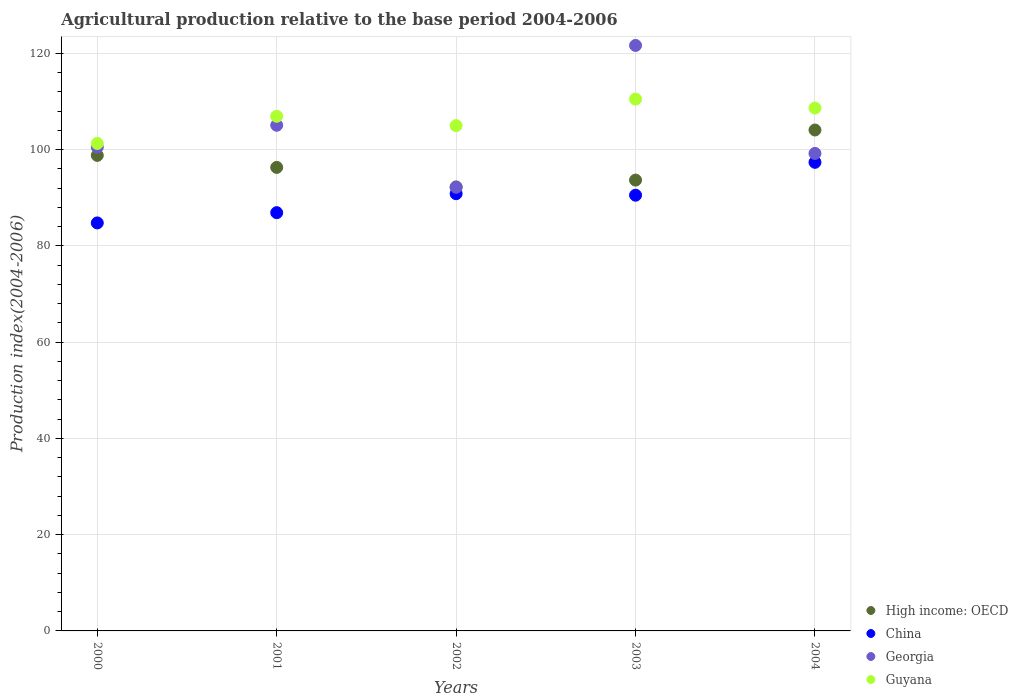Is the number of dotlines equal to the number of legend labels?
Offer a very short reply. Yes. What is the agricultural production index in Guyana in 2003?
Make the answer very short. 110.49. Across all years, what is the maximum agricultural production index in High income: OECD?
Ensure brevity in your answer.  104.06. Across all years, what is the minimum agricultural production index in Guyana?
Ensure brevity in your answer.  101.27. In which year was the agricultural production index in Georgia minimum?
Offer a very short reply. 2002. What is the total agricultural production index in Guyana in the graph?
Ensure brevity in your answer.  532.26. What is the difference between the agricultural production index in High income: OECD in 2000 and that in 2001?
Provide a succinct answer. 2.49. What is the difference between the agricultural production index in Guyana in 2003 and the agricultural production index in Georgia in 2000?
Offer a terse response. 9.99. What is the average agricultural production index in China per year?
Your response must be concise. 90.07. In the year 2003, what is the difference between the agricultural production index in Georgia and agricultural production index in China?
Make the answer very short. 31.11. What is the ratio of the agricultural production index in Georgia in 2000 to that in 2002?
Your answer should be compact. 1.09. Is the agricultural production index in Guyana in 2002 less than that in 2004?
Keep it short and to the point. Yes. Is the difference between the agricultural production index in Georgia in 2002 and 2004 greater than the difference between the agricultural production index in China in 2002 and 2004?
Provide a short and direct response. No. What is the difference between the highest and the second highest agricultural production index in China?
Your answer should be very brief. 6.52. What is the difference between the highest and the lowest agricultural production index in High income: OECD?
Provide a succinct answer. 11.82. Is it the case that in every year, the sum of the agricultural production index in High income: OECD and agricultural production index in China  is greater than the sum of agricultural production index in Georgia and agricultural production index in Guyana?
Ensure brevity in your answer.  No. Does the agricultural production index in Guyana monotonically increase over the years?
Provide a short and direct response. No. What is the difference between two consecutive major ticks on the Y-axis?
Offer a terse response. 20. Does the graph contain grids?
Offer a very short reply. Yes. How many legend labels are there?
Your answer should be very brief. 4. What is the title of the graph?
Your answer should be compact. Agricultural production relative to the base period 2004-2006. What is the label or title of the Y-axis?
Provide a short and direct response. Production index(2004-2006). What is the Production index(2004-2006) in High income: OECD in 2000?
Provide a succinct answer. 98.79. What is the Production index(2004-2006) in China in 2000?
Your answer should be very brief. 84.76. What is the Production index(2004-2006) of Georgia in 2000?
Your response must be concise. 100.5. What is the Production index(2004-2006) in Guyana in 2000?
Provide a succinct answer. 101.27. What is the Production index(2004-2006) of High income: OECD in 2001?
Keep it short and to the point. 96.3. What is the Production index(2004-2006) in China in 2001?
Your response must be concise. 86.89. What is the Production index(2004-2006) of Georgia in 2001?
Make the answer very short. 105.05. What is the Production index(2004-2006) of Guyana in 2001?
Your answer should be very brief. 106.91. What is the Production index(2004-2006) in High income: OECD in 2002?
Your answer should be compact. 92.24. What is the Production index(2004-2006) of China in 2002?
Your response must be concise. 90.83. What is the Production index(2004-2006) of Georgia in 2002?
Your answer should be compact. 92.16. What is the Production index(2004-2006) of Guyana in 2002?
Offer a terse response. 104.97. What is the Production index(2004-2006) of High income: OECD in 2003?
Make the answer very short. 93.66. What is the Production index(2004-2006) of China in 2003?
Your answer should be very brief. 90.52. What is the Production index(2004-2006) in Georgia in 2003?
Your answer should be very brief. 121.63. What is the Production index(2004-2006) in Guyana in 2003?
Keep it short and to the point. 110.49. What is the Production index(2004-2006) of High income: OECD in 2004?
Your answer should be very brief. 104.06. What is the Production index(2004-2006) in China in 2004?
Offer a very short reply. 97.35. What is the Production index(2004-2006) in Georgia in 2004?
Offer a terse response. 99.2. What is the Production index(2004-2006) of Guyana in 2004?
Give a very brief answer. 108.62. Across all years, what is the maximum Production index(2004-2006) in High income: OECD?
Ensure brevity in your answer.  104.06. Across all years, what is the maximum Production index(2004-2006) of China?
Keep it short and to the point. 97.35. Across all years, what is the maximum Production index(2004-2006) of Georgia?
Make the answer very short. 121.63. Across all years, what is the maximum Production index(2004-2006) in Guyana?
Your answer should be very brief. 110.49. Across all years, what is the minimum Production index(2004-2006) of High income: OECD?
Your response must be concise. 92.24. Across all years, what is the minimum Production index(2004-2006) of China?
Offer a terse response. 84.76. Across all years, what is the minimum Production index(2004-2006) of Georgia?
Offer a very short reply. 92.16. Across all years, what is the minimum Production index(2004-2006) of Guyana?
Your answer should be very brief. 101.27. What is the total Production index(2004-2006) in High income: OECD in the graph?
Offer a terse response. 485.04. What is the total Production index(2004-2006) in China in the graph?
Offer a terse response. 450.35. What is the total Production index(2004-2006) in Georgia in the graph?
Keep it short and to the point. 518.54. What is the total Production index(2004-2006) in Guyana in the graph?
Provide a succinct answer. 532.26. What is the difference between the Production index(2004-2006) of High income: OECD in 2000 and that in 2001?
Your answer should be very brief. 2.49. What is the difference between the Production index(2004-2006) of China in 2000 and that in 2001?
Provide a short and direct response. -2.13. What is the difference between the Production index(2004-2006) in Georgia in 2000 and that in 2001?
Your answer should be compact. -4.55. What is the difference between the Production index(2004-2006) of Guyana in 2000 and that in 2001?
Provide a succinct answer. -5.64. What is the difference between the Production index(2004-2006) of High income: OECD in 2000 and that in 2002?
Your response must be concise. 6.55. What is the difference between the Production index(2004-2006) of China in 2000 and that in 2002?
Your answer should be very brief. -6.07. What is the difference between the Production index(2004-2006) of Georgia in 2000 and that in 2002?
Your answer should be compact. 8.34. What is the difference between the Production index(2004-2006) in High income: OECD in 2000 and that in 2003?
Ensure brevity in your answer.  5.13. What is the difference between the Production index(2004-2006) in China in 2000 and that in 2003?
Your answer should be compact. -5.76. What is the difference between the Production index(2004-2006) in Georgia in 2000 and that in 2003?
Your response must be concise. -21.13. What is the difference between the Production index(2004-2006) of Guyana in 2000 and that in 2003?
Keep it short and to the point. -9.22. What is the difference between the Production index(2004-2006) of High income: OECD in 2000 and that in 2004?
Provide a succinct answer. -5.27. What is the difference between the Production index(2004-2006) of China in 2000 and that in 2004?
Ensure brevity in your answer.  -12.59. What is the difference between the Production index(2004-2006) in Guyana in 2000 and that in 2004?
Provide a succinct answer. -7.35. What is the difference between the Production index(2004-2006) of High income: OECD in 2001 and that in 2002?
Your answer should be very brief. 4.06. What is the difference between the Production index(2004-2006) of China in 2001 and that in 2002?
Offer a terse response. -3.94. What is the difference between the Production index(2004-2006) of Georgia in 2001 and that in 2002?
Give a very brief answer. 12.89. What is the difference between the Production index(2004-2006) of Guyana in 2001 and that in 2002?
Offer a terse response. 1.94. What is the difference between the Production index(2004-2006) in High income: OECD in 2001 and that in 2003?
Provide a succinct answer. 2.64. What is the difference between the Production index(2004-2006) of China in 2001 and that in 2003?
Ensure brevity in your answer.  -3.63. What is the difference between the Production index(2004-2006) of Georgia in 2001 and that in 2003?
Keep it short and to the point. -16.58. What is the difference between the Production index(2004-2006) in Guyana in 2001 and that in 2003?
Provide a succinct answer. -3.58. What is the difference between the Production index(2004-2006) in High income: OECD in 2001 and that in 2004?
Your response must be concise. -7.77. What is the difference between the Production index(2004-2006) in China in 2001 and that in 2004?
Make the answer very short. -10.46. What is the difference between the Production index(2004-2006) of Georgia in 2001 and that in 2004?
Keep it short and to the point. 5.85. What is the difference between the Production index(2004-2006) of Guyana in 2001 and that in 2004?
Provide a succinct answer. -1.71. What is the difference between the Production index(2004-2006) of High income: OECD in 2002 and that in 2003?
Make the answer very short. -1.42. What is the difference between the Production index(2004-2006) of China in 2002 and that in 2003?
Ensure brevity in your answer.  0.31. What is the difference between the Production index(2004-2006) of Georgia in 2002 and that in 2003?
Offer a very short reply. -29.47. What is the difference between the Production index(2004-2006) of Guyana in 2002 and that in 2003?
Offer a terse response. -5.52. What is the difference between the Production index(2004-2006) in High income: OECD in 2002 and that in 2004?
Provide a short and direct response. -11.82. What is the difference between the Production index(2004-2006) in China in 2002 and that in 2004?
Make the answer very short. -6.52. What is the difference between the Production index(2004-2006) in Georgia in 2002 and that in 2004?
Give a very brief answer. -7.04. What is the difference between the Production index(2004-2006) of Guyana in 2002 and that in 2004?
Provide a short and direct response. -3.65. What is the difference between the Production index(2004-2006) in High income: OECD in 2003 and that in 2004?
Provide a short and direct response. -10.41. What is the difference between the Production index(2004-2006) of China in 2003 and that in 2004?
Offer a terse response. -6.83. What is the difference between the Production index(2004-2006) of Georgia in 2003 and that in 2004?
Ensure brevity in your answer.  22.43. What is the difference between the Production index(2004-2006) in Guyana in 2003 and that in 2004?
Give a very brief answer. 1.87. What is the difference between the Production index(2004-2006) of High income: OECD in 2000 and the Production index(2004-2006) of China in 2001?
Give a very brief answer. 11.9. What is the difference between the Production index(2004-2006) of High income: OECD in 2000 and the Production index(2004-2006) of Georgia in 2001?
Your answer should be compact. -6.26. What is the difference between the Production index(2004-2006) in High income: OECD in 2000 and the Production index(2004-2006) in Guyana in 2001?
Make the answer very short. -8.12. What is the difference between the Production index(2004-2006) in China in 2000 and the Production index(2004-2006) in Georgia in 2001?
Your response must be concise. -20.29. What is the difference between the Production index(2004-2006) of China in 2000 and the Production index(2004-2006) of Guyana in 2001?
Offer a terse response. -22.15. What is the difference between the Production index(2004-2006) of Georgia in 2000 and the Production index(2004-2006) of Guyana in 2001?
Provide a succinct answer. -6.41. What is the difference between the Production index(2004-2006) in High income: OECD in 2000 and the Production index(2004-2006) in China in 2002?
Make the answer very short. 7.96. What is the difference between the Production index(2004-2006) in High income: OECD in 2000 and the Production index(2004-2006) in Georgia in 2002?
Provide a succinct answer. 6.63. What is the difference between the Production index(2004-2006) in High income: OECD in 2000 and the Production index(2004-2006) in Guyana in 2002?
Provide a short and direct response. -6.18. What is the difference between the Production index(2004-2006) of China in 2000 and the Production index(2004-2006) of Guyana in 2002?
Provide a succinct answer. -20.21. What is the difference between the Production index(2004-2006) in Georgia in 2000 and the Production index(2004-2006) in Guyana in 2002?
Offer a very short reply. -4.47. What is the difference between the Production index(2004-2006) in High income: OECD in 2000 and the Production index(2004-2006) in China in 2003?
Offer a very short reply. 8.27. What is the difference between the Production index(2004-2006) of High income: OECD in 2000 and the Production index(2004-2006) of Georgia in 2003?
Keep it short and to the point. -22.84. What is the difference between the Production index(2004-2006) in High income: OECD in 2000 and the Production index(2004-2006) in Guyana in 2003?
Your answer should be compact. -11.7. What is the difference between the Production index(2004-2006) in China in 2000 and the Production index(2004-2006) in Georgia in 2003?
Offer a very short reply. -36.87. What is the difference between the Production index(2004-2006) in China in 2000 and the Production index(2004-2006) in Guyana in 2003?
Your answer should be very brief. -25.73. What is the difference between the Production index(2004-2006) in Georgia in 2000 and the Production index(2004-2006) in Guyana in 2003?
Offer a very short reply. -9.99. What is the difference between the Production index(2004-2006) of High income: OECD in 2000 and the Production index(2004-2006) of China in 2004?
Offer a terse response. 1.44. What is the difference between the Production index(2004-2006) in High income: OECD in 2000 and the Production index(2004-2006) in Georgia in 2004?
Give a very brief answer. -0.41. What is the difference between the Production index(2004-2006) in High income: OECD in 2000 and the Production index(2004-2006) in Guyana in 2004?
Provide a short and direct response. -9.83. What is the difference between the Production index(2004-2006) of China in 2000 and the Production index(2004-2006) of Georgia in 2004?
Keep it short and to the point. -14.44. What is the difference between the Production index(2004-2006) of China in 2000 and the Production index(2004-2006) of Guyana in 2004?
Your response must be concise. -23.86. What is the difference between the Production index(2004-2006) in Georgia in 2000 and the Production index(2004-2006) in Guyana in 2004?
Offer a very short reply. -8.12. What is the difference between the Production index(2004-2006) in High income: OECD in 2001 and the Production index(2004-2006) in China in 2002?
Your answer should be compact. 5.47. What is the difference between the Production index(2004-2006) of High income: OECD in 2001 and the Production index(2004-2006) of Georgia in 2002?
Your answer should be very brief. 4.14. What is the difference between the Production index(2004-2006) in High income: OECD in 2001 and the Production index(2004-2006) in Guyana in 2002?
Offer a terse response. -8.67. What is the difference between the Production index(2004-2006) of China in 2001 and the Production index(2004-2006) of Georgia in 2002?
Ensure brevity in your answer.  -5.27. What is the difference between the Production index(2004-2006) in China in 2001 and the Production index(2004-2006) in Guyana in 2002?
Make the answer very short. -18.08. What is the difference between the Production index(2004-2006) in Georgia in 2001 and the Production index(2004-2006) in Guyana in 2002?
Offer a terse response. 0.08. What is the difference between the Production index(2004-2006) of High income: OECD in 2001 and the Production index(2004-2006) of China in 2003?
Give a very brief answer. 5.78. What is the difference between the Production index(2004-2006) of High income: OECD in 2001 and the Production index(2004-2006) of Georgia in 2003?
Offer a very short reply. -25.33. What is the difference between the Production index(2004-2006) in High income: OECD in 2001 and the Production index(2004-2006) in Guyana in 2003?
Your response must be concise. -14.19. What is the difference between the Production index(2004-2006) in China in 2001 and the Production index(2004-2006) in Georgia in 2003?
Make the answer very short. -34.74. What is the difference between the Production index(2004-2006) in China in 2001 and the Production index(2004-2006) in Guyana in 2003?
Provide a succinct answer. -23.6. What is the difference between the Production index(2004-2006) of Georgia in 2001 and the Production index(2004-2006) of Guyana in 2003?
Offer a very short reply. -5.44. What is the difference between the Production index(2004-2006) of High income: OECD in 2001 and the Production index(2004-2006) of China in 2004?
Ensure brevity in your answer.  -1.05. What is the difference between the Production index(2004-2006) of High income: OECD in 2001 and the Production index(2004-2006) of Georgia in 2004?
Keep it short and to the point. -2.9. What is the difference between the Production index(2004-2006) of High income: OECD in 2001 and the Production index(2004-2006) of Guyana in 2004?
Give a very brief answer. -12.32. What is the difference between the Production index(2004-2006) in China in 2001 and the Production index(2004-2006) in Georgia in 2004?
Give a very brief answer. -12.31. What is the difference between the Production index(2004-2006) of China in 2001 and the Production index(2004-2006) of Guyana in 2004?
Your answer should be compact. -21.73. What is the difference between the Production index(2004-2006) in Georgia in 2001 and the Production index(2004-2006) in Guyana in 2004?
Your answer should be compact. -3.57. What is the difference between the Production index(2004-2006) of High income: OECD in 2002 and the Production index(2004-2006) of China in 2003?
Make the answer very short. 1.72. What is the difference between the Production index(2004-2006) of High income: OECD in 2002 and the Production index(2004-2006) of Georgia in 2003?
Make the answer very short. -29.39. What is the difference between the Production index(2004-2006) of High income: OECD in 2002 and the Production index(2004-2006) of Guyana in 2003?
Offer a very short reply. -18.25. What is the difference between the Production index(2004-2006) in China in 2002 and the Production index(2004-2006) in Georgia in 2003?
Make the answer very short. -30.8. What is the difference between the Production index(2004-2006) in China in 2002 and the Production index(2004-2006) in Guyana in 2003?
Your answer should be very brief. -19.66. What is the difference between the Production index(2004-2006) of Georgia in 2002 and the Production index(2004-2006) of Guyana in 2003?
Offer a very short reply. -18.33. What is the difference between the Production index(2004-2006) of High income: OECD in 2002 and the Production index(2004-2006) of China in 2004?
Your response must be concise. -5.11. What is the difference between the Production index(2004-2006) of High income: OECD in 2002 and the Production index(2004-2006) of Georgia in 2004?
Your response must be concise. -6.96. What is the difference between the Production index(2004-2006) of High income: OECD in 2002 and the Production index(2004-2006) of Guyana in 2004?
Ensure brevity in your answer.  -16.38. What is the difference between the Production index(2004-2006) of China in 2002 and the Production index(2004-2006) of Georgia in 2004?
Your answer should be very brief. -8.37. What is the difference between the Production index(2004-2006) of China in 2002 and the Production index(2004-2006) of Guyana in 2004?
Provide a succinct answer. -17.79. What is the difference between the Production index(2004-2006) of Georgia in 2002 and the Production index(2004-2006) of Guyana in 2004?
Provide a succinct answer. -16.46. What is the difference between the Production index(2004-2006) in High income: OECD in 2003 and the Production index(2004-2006) in China in 2004?
Your response must be concise. -3.69. What is the difference between the Production index(2004-2006) of High income: OECD in 2003 and the Production index(2004-2006) of Georgia in 2004?
Provide a short and direct response. -5.54. What is the difference between the Production index(2004-2006) in High income: OECD in 2003 and the Production index(2004-2006) in Guyana in 2004?
Your answer should be very brief. -14.96. What is the difference between the Production index(2004-2006) in China in 2003 and the Production index(2004-2006) in Georgia in 2004?
Offer a terse response. -8.68. What is the difference between the Production index(2004-2006) in China in 2003 and the Production index(2004-2006) in Guyana in 2004?
Ensure brevity in your answer.  -18.1. What is the difference between the Production index(2004-2006) in Georgia in 2003 and the Production index(2004-2006) in Guyana in 2004?
Your answer should be very brief. 13.01. What is the average Production index(2004-2006) of High income: OECD per year?
Offer a very short reply. 97.01. What is the average Production index(2004-2006) in China per year?
Make the answer very short. 90.07. What is the average Production index(2004-2006) in Georgia per year?
Provide a succinct answer. 103.71. What is the average Production index(2004-2006) in Guyana per year?
Offer a terse response. 106.45. In the year 2000, what is the difference between the Production index(2004-2006) in High income: OECD and Production index(2004-2006) in China?
Your response must be concise. 14.03. In the year 2000, what is the difference between the Production index(2004-2006) of High income: OECD and Production index(2004-2006) of Georgia?
Provide a short and direct response. -1.71. In the year 2000, what is the difference between the Production index(2004-2006) of High income: OECD and Production index(2004-2006) of Guyana?
Provide a succinct answer. -2.48. In the year 2000, what is the difference between the Production index(2004-2006) in China and Production index(2004-2006) in Georgia?
Keep it short and to the point. -15.74. In the year 2000, what is the difference between the Production index(2004-2006) of China and Production index(2004-2006) of Guyana?
Your response must be concise. -16.51. In the year 2000, what is the difference between the Production index(2004-2006) in Georgia and Production index(2004-2006) in Guyana?
Your answer should be very brief. -0.77. In the year 2001, what is the difference between the Production index(2004-2006) of High income: OECD and Production index(2004-2006) of China?
Ensure brevity in your answer.  9.41. In the year 2001, what is the difference between the Production index(2004-2006) in High income: OECD and Production index(2004-2006) in Georgia?
Offer a very short reply. -8.75. In the year 2001, what is the difference between the Production index(2004-2006) in High income: OECD and Production index(2004-2006) in Guyana?
Your response must be concise. -10.61. In the year 2001, what is the difference between the Production index(2004-2006) in China and Production index(2004-2006) in Georgia?
Make the answer very short. -18.16. In the year 2001, what is the difference between the Production index(2004-2006) in China and Production index(2004-2006) in Guyana?
Your answer should be compact. -20.02. In the year 2001, what is the difference between the Production index(2004-2006) in Georgia and Production index(2004-2006) in Guyana?
Your answer should be very brief. -1.86. In the year 2002, what is the difference between the Production index(2004-2006) in High income: OECD and Production index(2004-2006) in China?
Provide a succinct answer. 1.41. In the year 2002, what is the difference between the Production index(2004-2006) in High income: OECD and Production index(2004-2006) in Georgia?
Your response must be concise. 0.08. In the year 2002, what is the difference between the Production index(2004-2006) of High income: OECD and Production index(2004-2006) of Guyana?
Offer a very short reply. -12.73. In the year 2002, what is the difference between the Production index(2004-2006) of China and Production index(2004-2006) of Georgia?
Your answer should be compact. -1.33. In the year 2002, what is the difference between the Production index(2004-2006) in China and Production index(2004-2006) in Guyana?
Make the answer very short. -14.14. In the year 2002, what is the difference between the Production index(2004-2006) of Georgia and Production index(2004-2006) of Guyana?
Make the answer very short. -12.81. In the year 2003, what is the difference between the Production index(2004-2006) of High income: OECD and Production index(2004-2006) of China?
Provide a short and direct response. 3.14. In the year 2003, what is the difference between the Production index(2004-2006) of High income: OECD and Production index(2004-2006) of Georgia?
Make the answer very short. -27.97. In the year 2003, what is the difference between the Production index(2004-2006) in High income: OECD and Production index(2004-2006) in Guyana?
Make the answer very short. -16.83. In the year 2003, what is the difference between the Production index(2004-2006) of China and Production index(2004-2006) of Georgia?
Provide a succinct answer. -31.11. In the year 2003, what is the difference between the Production index(2004-2006) of China and Production index(2004-2006) of Guyana?
Give a very brief answer. -19.97. In the year 2003, what is the difference between the Production index(2004-2006) of Georgia and Production index(2004-2006) of Guyana?
Provide a succinct answer. 11.14. In the year 2004, what is the difference between the Production index(2004-2006) of High income: OECD and Production index(2004-2006) of China?
Make the answer very short. 6.71. In the year 2004, what is the difference between the Production index(2004-2006) of High income: OECD and Production index(2004-2006) of Georgia?
Your response must be concise. 4.86. In the year 2004, what is the difference between the Production index(2004-2006) in High income: OECD and Production index(2004-2006) in Guyana?
Provide a short and direct response. -4.56. In the year 2004, what is the difference between the Production index(2004-2006) of China and Production index(2004-2006) of Georgia?
Give a very brief answer. -1.85. In the year 2004, what is the difference between the Production index(2004-2006) in China and Production index(2004-2006) in Guyana?
Offer a terse response. -11.27. In the year 2004, what is the difference between the Production index(2004-2006) of Georgia and Production index(2004-2006) of Guyana?
Make the answer very short. -9.42. What is the ratio of the Production index(2004-2006) of High income: OECD in 2000 to that in 2001?
Provide a succinct answer. 1.03. What is the ratio of the Production index(2004-2006) of China in 2000 to that in 2001?
Your response must be concise. 0.98. What is the ratio of the Production index(2004-2006) of Georgia in 2000 to that in 2001?
Make the answer very short. 0.96. What is the ratio of the Production index(2004-2006) in Guyana in 2000 to that in 2001?
Your answer should be very brief. 0.95. What is the ratio of the Production index(2004-2006) in High income: OECD in 2000 to that in 2002?
Ensure brevity in your answer.  1.07. What is the ratio of the Production index(2004-2006) of China in 2000 to that in 2002?
Provide a succinct answer. 0.93. What is the ratio of the Production index(2004-2006) of Georgia in 2000 to that in 2002?
Your answer should be compact. 1.09. What is the ratio of the Production index(2004-2006) of Guyana in 2000 to that in 2002?
Provide a short and direct response. 0.96. What is the ratio of the Production index(2004-2006) of High income: OECD in 2000 to that in 2003?
Offer a terse response. 1.05. What is the ratio of the Production index(2004-2006) in China in 2000 to that in 2003?
Provide a short and direct response. 0.94. What is the ratio of the Production index(2004-2006) of Georgia in 2000 to that in 2003?
Your answer should be compact. 0.83. What is the ratio of the Production index(2004-2006) of Guyana in 2000 to that in 2003?
Give a very brief answer. 0.92. What is the ratio of the Production index(2004-2006) of High income: OECD in 2000 to that in 2004?
Offer a terse response. 0.95. What is the ratio of the Production index(2004-2006) in China in 2000 to that in 2004?
Make the answer very short. 0.87. What is the ratio of the Production index(2004-2006) of Georgia in 2000 to that in 2004?
Make the answer very short. 1.01. What is the ratio of the Production index(2004-2006) in Guyana in 2000 to that in 2004?
Offer a very short reply. 0.93. What is the ratio of the Production index(2004-2006) in High income: OECD in 2001 to that in 2002?
Your answer should be very brief. 1.04. What is the ratio of the Production index(2004-2006) of China in 2001 to that in 2002?
Ensure brevity in your answer.  0.96. What is the ratio of the Production index(2004-2006) of Georgia in 2001 to that in 2002?
Give a very brief answer. 1.14. What is the ratio of the Production index(2004-2006) in Guyana in 2001 to that in 2002?
Ensure brevity in your answer.  1.02. What is the ratio of the Production index(2004-2006) in High income: OECD in 2001 to that in 2003?
Offer a very short reply. 1.03. What is the ratio of the Production index(2004-2006) of China in 2001 to that in 2003?
Give a very brief answer. 0.96. What is the ratio of the Production index(2004-2006) in Georgia in 2001 to that in 2003?
Your response must be concise. 0.86. What is the ratio of the Production index(2004-2006) of Guyana in 2001 to that in 2003?
Your response must be concise. 0.97. What is the ratio of the Production index(2004-2006) of High income: OECD in 2001 to that in 2004?
Make the answer very short. 0.93. What is the ratio of the Production index(2004-2006) in China in 2001 to that in 2004?
Provide a succinct answer. 0.89. What is the ratio of the Production index(2004-2006) in Georgia in 2001 to that in 2004?
Keep it short and to the point. 1.06. What is the ratio of the Production index(2004-2006) in Guyana in 2001 to that in 2004?
Provide a short and direct response. 0.98. What is the ratio of the Production index(2004-2006) in High income: OECD in 2002 to that in 2003?
Your answer should be compact. 0.98. What is the ratio of the Production index(2004-2006) of Georgia in 2002 to that in 2003?
Provide a short and direct response. 0.76. What is the ratio of the Production index(2004-2006) in Guyana in 2002 to that in 2003?
Keep it short and to the point. 0.95. What is the ratio of the Production index(2004-2006) in High income: OECD in 2002 to that in 2004?
Ensure brevity in your answer.  0.89. What is the ratio of the Production index(2004-2006) of China in 2002 to that in 2004?
Keep it short and to the point. 0.93. What is the ratio of the Production index(2004-2006) of Georgia in 2002 to that in 2004?
Provide a succinct answer. 0.93. What is the ratio of the Production index(2004-2006) of Guyana in 2002 to that in 2004?
Your answer should be compact. 0.97. What is the ratio of the Production index(2004-2006) of China in 2003 to that in 2004?
Give a very brief answer. 0.93. What is the ratio of the Production index(2004-2006) of Georgia in 2003 to that in 2004?
Ensure brevity in your answer.  1.23. What is the ratio of the Production index(2004-2006) of Guyana in 2003 to that in 2004?
Your answer should be compact. 1.02. What is the difference between the highest and the second highest Production index(2004-2006) of High income: OECD?
Ensure brevity in your answer.  5.27. What is the difference between the highest and the second highest Production index(2004-2006) of China?
Give a very brief answer. 6.52. What is the difference between the highest and the second highest Production index(2004-2006) of Georgia?
Offer a terse response. 16.58. What is the difference between the highest and the second highest Production index(2004-2006) in Guyana?
Keep it short and to the point. 1.87. What is the difference between the highest and the lowest Production index(2004-2006) in High income: OECD?
Give a very brief answer. 11.82. What is the difference between the highest and the lowest Production index(2004-2006) in China?
Keep it short and to the point. 12.59. What is the difference between the highest and the lowest Production index(2004-2006) in Georgia?
Offer a terse response. 29.47. What is the difference between the highest and the lowest Production index(2004-2006) in Guyana?
Your response must be concise. 9.22. 